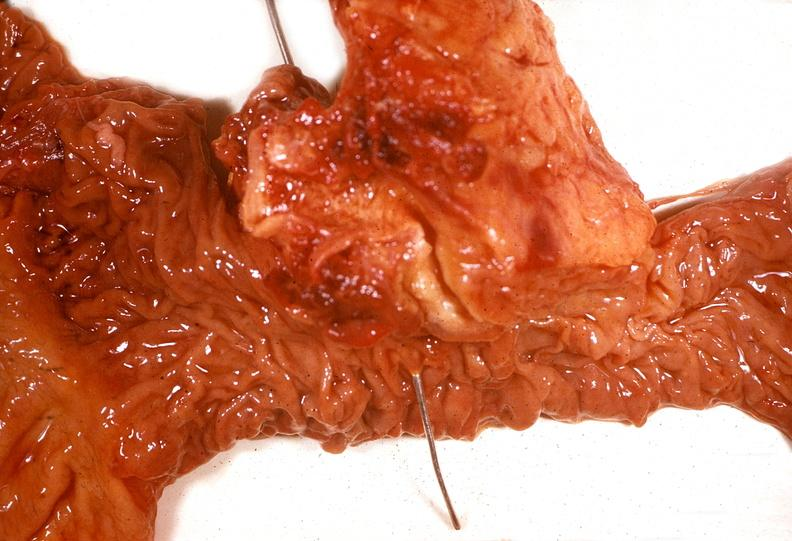does stress show adenocarcinoma, head of pancreas?
Answer the question using a single word or phrase. No 